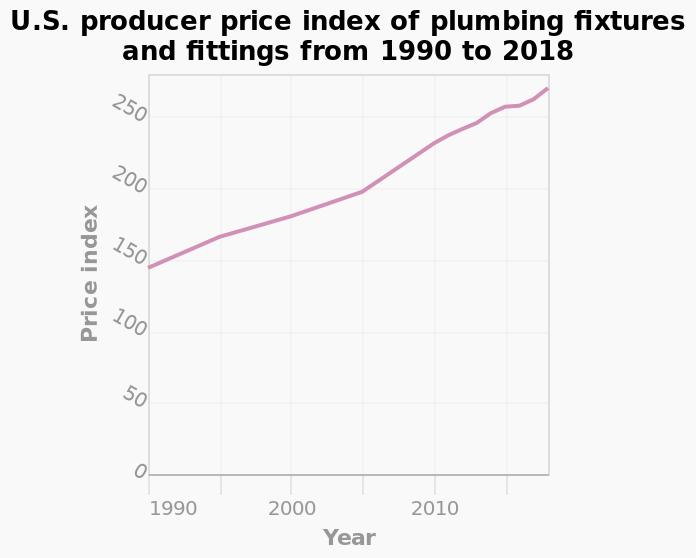<image>
During which period did the quickest increase in price index occur?  The quickest increase in price index occurred between 2005 and 2013. What is the range of the y-axis? The y-axis shows the Price index using a linear scale from 0 to 250. 